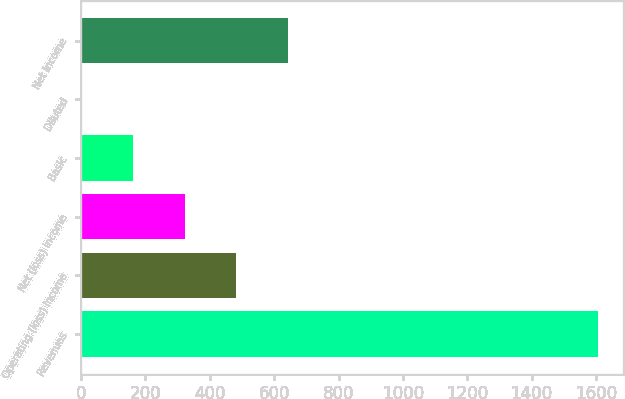Convert chart. <chart><loc_0><loc_0><loc_500><loc_500><bar_chart><fcel>Revenues<fcel>Operating (loss) income<fcel>Net (loss) income<fcel>Basic<fcel>Diluted<fcel>Net income<nl><fcel>1605<fcel>481.94<fcel>321.5<fcel>161.06<fcel>0.62<fcel>642.38<nl></chart> 